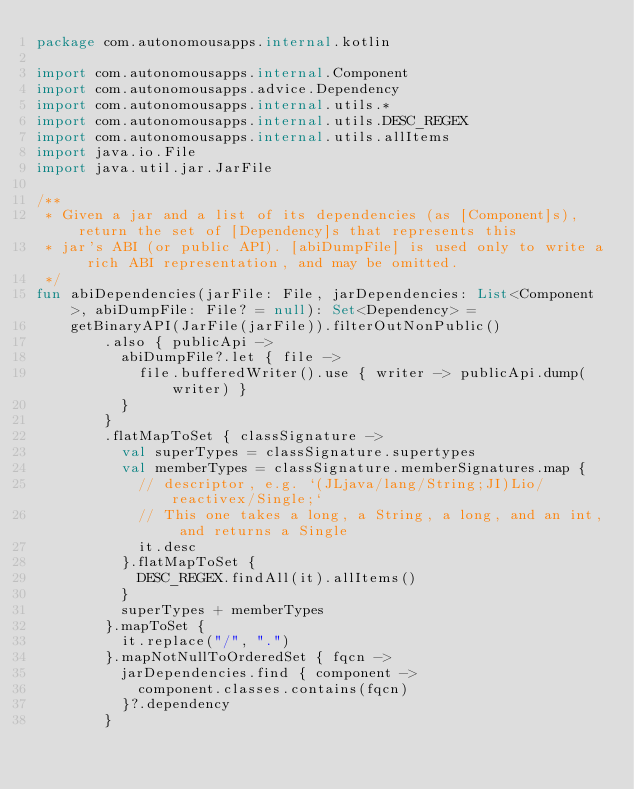<code> <loc_0><loc_0><loc_500><loc_500><_Kotlin_>package com.autonomousapps.internal.kotlin

import com.autonomousapps.internal.Component
import com.autonomousapps.advice.Dependency
import com.autonomousapps.internal.utils.*
import com.autonomousapps.internal.utils.DESC_REGEX
import com.autonomousapps.internal.utils.allItems
import java.io.File
import java.util.jar.JarFile

/**
 * Given a jar and a list of its dependencies (as [Component]s), return the set of [Dependency]s that represents this
 * jar's ABI (or public API). [abiDumpFile] is used only to write a rich ABI representation, and may be omitted.
 */
fun abiDependencies(jarFile: File, jarDependencies: List<Component>, abiDumpFile: File? = null): Set<Dependency> =
    getBinaryAPI(JarFile(jarFile)).filterOutNonPublic()
        .also { publicApi ->
          abiDumpFile?.let { file ->
            file.bufferedWriter().use { writer -> publicApi.dump(writer) }
          }
        }
        .flatMapToSet { classSignature ->
          val superTypes = classSignature.supertypes
          val memberTypes = classSignature.memberSignatures.map {
            // descriptor, e.g. `(JLjava/lang/String;JI)Lio/reactivex/Single;`
            // This one takes a long, a String, a long, and an int, and returns a Single
            it.desc
          }.flatMapToSet {
            DESC_REGEX.findAll(it).allItems()
          }
          superTypes + memberTypes
        }.mapToSet {
          it.replace("/", ".")
        }.mapNotNullToOrderedSet { fqcn ->
          jarDependencies.find { component ->
            component.classes.contains(fqcn)
          }?.dependency
        }
</code> 